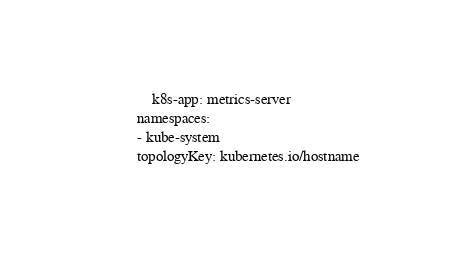Convert code to text. <code><loc_0><loc_0><loc_500><loc_500><_YAML_>                k8s-app: metrics-server
            namespaces:
            - kube-system
            topologyKey: kubernetes.io/hostname
</code> 